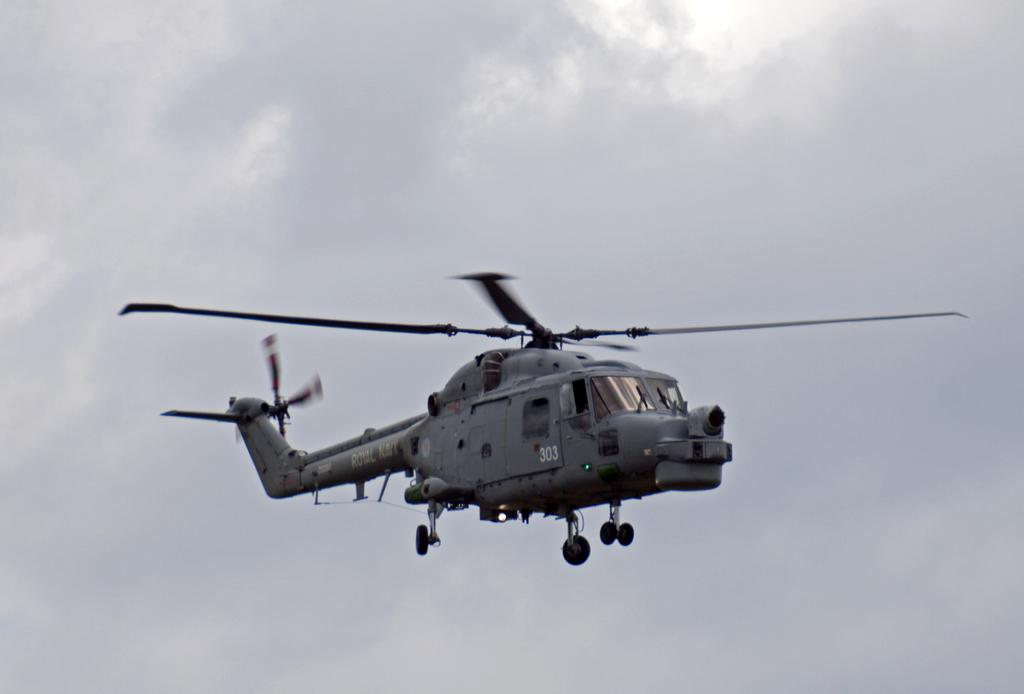What is the main subject of the image? The main subject of the image is a helicopter. Can you describe the location of the helicopter in the image? The helicopter is in the sky. How would you describe the weather based on the image? The sky is cloudy in the image. What type of beetle can be seen crawling on the helicopter in the image? There is no beetle present on the helicopter in the image. Is there a camera attached to the helicopter in the image? The image does not provide information about any cameras attached to the helicopter. Can you see a baseball game happening in the background of the image? There is no indication of a baseball game or any sports event in the image. 